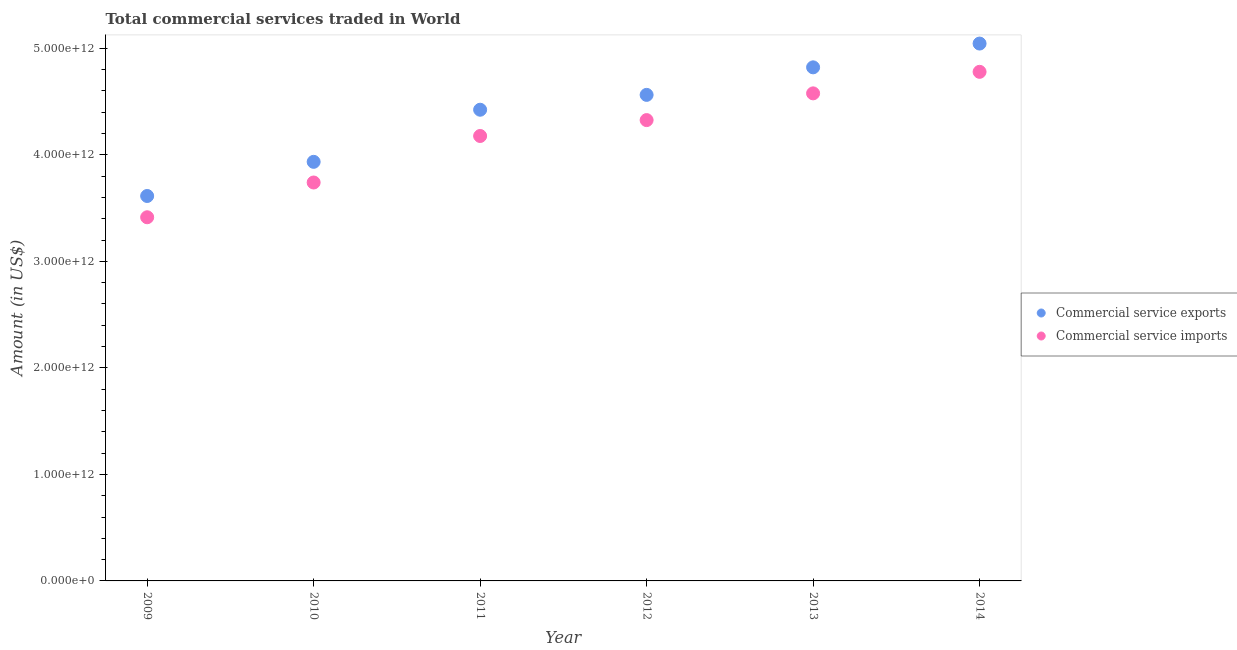What is the amount of commercial service exports in 2011?
Your answer should be compact. 4.42e+12. Across all years, what is the maximum amount of commercial service imports?
Your response must be concise. 4.78e+12. Across all years, what is the minimum amount of commercial service exports?
Keep it short and to the point. 3.61e+12. In which year was the amount of commercial service imports minimum?
Give a very brief answer. 2009. What is the total amount of commercial service exports in the graph?
Make the answer very short. 2.64e+13. What is the difference between the amount of commercial service exports in 2011 and that in 2014?
Provide a succinct answer. -6.21e+11. What is the difference between the amount of commercial service exports in 2011 and the amount of commercial service imports in 2012?
Give a very brief answer. 9.73e+1. What is the average amount of commercial service imports per year?
Your response must be concise. 4.17e+12. In the year 2013, what is the difference between the amount of commercial service exports and amount of commercial service imports?
Provide a short and direct response. 2.44e+11. In how many years, is the amount of commercial service exports greater than 1000000000000 US$?
Your answer should be compact. 6. What is the ratio of the amount of commercial service imports in 2011 to that in 2014?
Keep it short and to the point. 0.87. Is the amount of commercial service imports in 2010 less than that in 2011?
Make the answer very short. Yes. What is the difference between the highest and the second highest amount of commercial service imports?
Provide a succinct answer. 2.02e+11. What is the difference between the highest and the lowest amount of commercial service imports?
Provide a short and direct response. 1.37e+12. In how many years, is the amount of commercial service imports greater than the average amount of commercial service imports taken over all years?
Offer a terse response. 4. Is the sum of the amount of commercial service imports in 2011 and 2012 greater than the maximum amount of commercial service exports across all years?
Give a very brief answer. Yes. Is the amount of commercial service exports strictly greater than the amount of commercial service imports over the years?
Your answer should be very brief. Yes. What is the difference between two consecutive major ticks on the Y-axis?
Ensure brevity in your answer.  1.00e+12. Are the values on the major ticks of Y-axis written in scientific E-notation?
Provide a succinct answer. Yes. How are the legend labels stacked?
Make the answer very short. Vertical. What is the title of the graph?
Your response must be concise. Total commercial services traded in World. Does "Private creditors" appear as one of the legend labels in the graph?
Your answer should be very brief. No. What is the label or title of the Y-axis?
Make the answer very short. Amount (in US$). What is the Amount (in US$) of Commercial service exports in 2009?
Offer a very short reply. 3.61e+12. What is the Amount (in US$) of Commercial service imports in 2009?
Your response must be concise. 3.41e+12. What is the Amount (in US$) of Commercial service exports in 2010?
Offer a very short reply. 3.93e+12. What is the Amount (in US$) of Commercial service imports in 2010?
Make the answer very short. 3.74e+12. What is the Amount (in US$) in Commercial service exports in 2011?
Your answer should be very brief. 4.42e+12. What is the Amount (in US$) in Commercial service imports in 2011?
Your answer should be very brief. 4.18e+12. What is the Amount (in US$) of Commercial service exports in 2012?
Keep it short and to the point. 4.56e+12. What is the Amount (in US$) of Commercial service imports in 2012?
Your answer should be very brief. 4.33e+12. What is the Amount (in US$) of Commercial service exports in 2013?
Your answer should be very brief. 4.82e+12. What is the Amount (in US$) in Commercial service imports in 2013?
Keep it short and to the point. 4.58e+12. What is the Amount (in US$) of Commercial service exports in 2014?
Provide a succinct answer. 5.04e+12. What is the Amount (in US$) in Commercial service imports in 2014?
Ensure brevity in your answer.  4.78e+12. Across all years, what is the maximum Amount (in US$) in Commercial service exports?
Make the answer very short. 5.04e+12. Across all years, what is the maximum Amount (in US$) of Commercial service imports?
Provide a succinct answer. 4.78e+12. Across all years, what is the minimum Amount (in US$) in Commercial service exports?
Make the answer very short. 3.61e+12. Across all years, what is the minimum Amount (in US$) in Commercial service imports?
Provide a succinct answer. 3.41e+12. What is the total Amount (in US$) of Commercial service exports in the graph?
Ensure brevity in your answer.  2.64e+13. What is the total Amount (in US$) of Commercial service imports in the graph?
Your answer should be very brief. 2.50e+13. What is the difference between the Amount (in US$) in Commercial service exports in 2009 and that in 2010?
Ensure brevity in your answer.  -3.21e+11. What is the difference between the Amount (in US$) of Commercial service imports in 2009 and that in 2010?
Your response must be concise. -3.26e+11. What is the difference between the Amount (in US$) in Commercial service exports in 2009 and that in 2011?
Your response must be concise. -8.10e+11. What is the difference between the Amount (in US$) of Commercial service imports in 2009 and that in 2011?
Give a very brief answer. -7.63e+11. What is the difference between the Amount (in US$) in Commercial service exports in 2009 and that in 2012?
Your answer should be very brief. -9.49e+11. What is the difference between the Amount (in US$) in Commercial service imports in 2009 and that in 2012?
Provide a succinct answer. -9.12e+11. What is the difference between the Amount (in US$) of Commercial service exports in 2009 and that in 2013?
Give a very brief answer. -1.21e+12. What is the difference between the Amount (in US$) in Commercial service imports in 2009 and that in 2013?
Give a very brief answer. -1.16e+12. What is the difference between the Amount (in US$) in Commercial service exports in 2009 and that in 2014?
Provide a short and direct response. -1.43e+12. What is the difference between the Amount (in US$) in Commercial service imports in 2009 and that in 2014?
Provide a short and direct response. -1.37e+12. What is the difference between the Amount (in US$) in Commercial service exports in 2010 and that in 2011?
Your answer should be compact. -4.89e+11. What is the difference between the Amount (in US$) in Commercial service imports in 2010 and that in 2011?
Make the answer very short. -4.37e+11. What is the difference between the Amount (in US$) of Commercial service exports in 2010 and that in 2012?
Your response must be concise. -6.29e+11. What is the difference between the Amount (in US$) of Commercial service imports in 2010 and that in 2012?
Ensure brevity in your answer.  -5.86e+11. What is the difference between the Amount (in US$) of Commercial service exports in 2010 and that in 2013?
Provide a short and direct response. -8.87e+11. What is the difference between the Amount (in US$) of Commercial service imports in 2010 and that in 2013?
Offer a terse response. -8.37e+11. What is the difference between the Amount (in US$) in Commercial service exports in 2010 and that in 2014?
Make the answer very short. -1.11e+12. What is the difference between the Amount (in US$) of Commercial service imports in 2010 and that in 2014?
Ensure brevity in your answer.  -1.04e+12. What is the difference between the Amount (in US$) of Commercial service exports in 2011 and that in 2012?
Provide a succinct answer. -1.39e+11. What is the difference between the Amount (in US$) of Commercial service imports in 2011 and that in 2012?
Your response must be concise. -1.49e+11. What is the difference between the Amount (in US$) of Commercial service exports in 2011 and that in 2013?
Provide a succinct answer. -3.98e+11. What is the difference between the Amount (in US$) of Commercial service imports in 2011 and that in 2013?
Give a very brief answer. -4.00e+11. What is the difference between the Amount (in US$) of Commercial service exports in 2011 and that in 2014?
Your response must be concise. -6.21e+11. What is the difference between the Amount (in US$) in Commercial service imports in 2011 and that in 2014?
Your answer should be very brief. -6.02e+11. What is the difference between the Amount (in US$) in Commercial service exports in 2012 and that in 2013?
Offer a very short reply. -2.58e+11. What is the difference between the Amount (in US$) in Commercial service imports in 2012 and that in 2013?
Make the answer very short. -2.51e+11. What is the difference between the Amount (in US$) in Commercial service exports in 2012 and that in 2014?
Provide a succinct answer. -4.82e+11. What is the difference between the Amount (in US$) of Commercial service imports in 2012 and that in 2014?
Offer a very short reply. -4.53e+11. What is the difference between the Amount (in US$) in Commercial service exports in 2013 and that in 2014?
Your answer should be compact. -2.23e+11. What is the difference between the Amount (in US$) of Commercial service imports in 2013 and that in 2014?
Your answer should be compact. -2.02e+11. What is the difference between the Amount (in US$) of Commercial service exports in 2009 and the Amount (in US$) of Commercial service imports in 2010?
Offer a terse response. -1.27e+11. What is the difference between the Amount (in US$) in Commercial service exports in 2009 and the Amount (in US$) in Commercial service imports in 2011?
Offer a terse response. -5.63e+11. What is the difference between the Amount (in US$) in Commercial service exports in 2009 and the Amount (in US$) in Commercial service imports in 2012?
Provide a short and direct response. -7.12e+11. What is the difference between the Amount (in US$) of Commercial service exports in 2009 and the Amount (in US$) of Commercial service imports in 2013?
Offer a terse response. -9.63e+11. What is the difference between the Amount (in US$) in Commercial service exports in 2009 and the Amount (in US$) in Commercial service imports in 2014?
Keep it short and to the point. -1.17e+12. What is the difference between the Amount (in US$) in Commercial service exports in 2010 and the Amount (in US$) in Commercial service imports in 2011?
Make the answer very short. -2.43e+11. What is the difference between the Amount (in US$) of Commercial service exports in 2010 and the Amount (in US$) of Commercial service imports in 2012?
Make the answer very short. -3.92e+11. What is the difference between the Amount (in US$) in Commercial service exports in 2010 and the Amount (in US$) in Commercial service imports in 2013?
Make the answer very short. -6.43e+11. What is the difference between the Amount (in US$) in Commercial service exports in 2010 and the Amount (in US$) in Commercial service imports in 2014?
Give a very brief answer. -8.45e+11. What is the difference between the Amount (in US$) in Commercial service exports in 2011 and the Amount (in US$) in Commercial service imports in 2012?
Ensure brevity in your answer.  9.73e+1. What is the difference between the Amount (in US$) of Commercial service exports in 2011 and the Amount (in US$) of Commercial service imports in 2013?
Keep it short and to the point. -1.54e+11. What is the difference between the Amount (in US$) of Commercial service exports in 2011 and the Amount (in US$) of Commercial service imports in 2014?
Provide a succinct answer. -3.56e+11. What is the difference between the Amount (in US$) of Commercial service exports in 2012 and the Amount (in US$) of Commercial service imports in 2013?
Provide a short and direct response. -1.42e+1. What is the difference between the Amount (in US$) of Commercial service exports in 2012 and the Amount (in US$) of Commercial service imports in 2014?
Your answer should be very brief. -2.16e+11. What is the difference between the Amount (in US$) of Commercial service exports in 2013 and the Amount (in US$) of Commercial service imports in 2014?
Offer a terse response. 4.22e+1. What is the average Amount (in US$) of Commercial service exports per year?
Your answer should be very brief. 4.40e+12. What is the average Amount (in US$) of Commercial service imports per year?
Make the answer very short. 4.17e+12. In the year 2009, what is the difference between the Amount (in US$) in Commercial service exports and Amount (in US$) in Commercial service imports?
Your answer should be compact. 2.00e+11. In the year 2010, what is the difference between the Amount (in US$) in Commercial service exports and Amount (in US$) in Commercial service imports?
Provide a short and direct response. 1.94e+11. In the year 2011, what is the difference between the Amount (in US$) of Commercial service exports and Amount (in US$) of Commercial service imports?
Give a very brief answer. 2.46e+11. In the year 2012, what is the difference between the Amount (in US$) in Commercial service exports and Amount (in US$) in Commercial service imports?
Provide a succinct answer. 2.37e+11. In the year 2013, what is the difference between the Amount (in US$) in Commercial service exports and Amount (in US$) in Commercial service imports?
Your answer should be very brief. 2.44e+11. In the year 2014, what is the difference between the Amount (in US$) in Commercial service exports and Amount (in US$) in Commercial service imports?
Your answer should be compact. 2.65e+11. What is the ratio of the Amount (in US$) in Commercial service exports in 2009 to that in 2010?
Keep it short and to the point. 0.92. What is the ratio of the Amount (in US$) of Commercial service imports in 2009 to that in 2010?
Ensure brevity in your answer.  0.91. What is the ratio of the Amount (in US$) in Commercial service exports in 2009 to that in 2011?
Your answer should be compact. 0.82. What is the ratio of the Amount (in US$) in Commercial service imports in 2009 to that in 2011?
Your answer should be compact. 0.82. What is the ratio of the Amount (in US$) of Commercial service exports in 2009 to that in 2012?
Provide a succinct answer. 0.79. What is the ratio of the Amount (in US$) in Commercial service imports in 2009 to that in 2012?
Provide a short and direct response. 0.79. What is the ratio of the Amount (in US$) in Commercial service exports in 2009 to that in 2013?
Offer a terse response. 0.75. What is the ratio of the Amount (in US$) of Commercial service imports in 2009 to that in 2013?
Keep it short and to the point. 0.75. What is the ratio of the Amount (in US$) in Commercial service exports in 2009 to that in 2014?
Keep it short and to the point. 0.72. What is the ratio of the Amount (in US$) of Commercial service exports in 2010 to that in 2011?
Ensure brevity in your answer.  0.89. What is the ratio of the Amount (in US$) in Commercial service imports in 2010 to that in 2011?
Provide a short and direct response. 0.9. What is the ratio of the Amount (in US$) in Commercial service exports in 2010 to that in 2012?
Offer a terse response. 0.86. What is the ratio of the Amount (in US$) of Commercial service imports in 2010 to that in 2012?
Provide a succinct answer. 0.86. What is the ratio of the Amount (in US$) in Commercial service exports in 2010 to that in 2013?
Keep it short and to the point. 0.82. What is the ratio of the Amount (in US$) in Commercial service imports in 2010 to that in 2013?
Give a very brief answer. 0.82. What is the ratio of the Amount (in US$) of Commercial service exports in 2010 to that in 2014?
Your response must be concise. 0.78. What is the ratio of the Amount (in US$) of Commercial service imports in 2010 to that in 2014?
Offer a terse response. 0.78. What is the ratio of the Amount (in US$) in Commercial service exports in 2011 to that in 2012?
Give a very brief answer. 0.97. What is the ratio of the Amount (in US$) in Commercial service imports in 2011 to that in 2012?
Your answer should be very brief. 0.97. What is the ratio of the Amount (in US$) in Commercial service exports in 2011 to that in 2013?
Your answer should be compact. 0.92. What is the ratio of the Amount (in US$) in Commercial service imports in 2011 to that in 2013?
Provide a short and direct response. 0.91. What is the ratio of the Amount (in US$) in Commercial service exports in 2011 to that in 2014?
Your answer should be compact. 0.88. What is the ratio of the Amount (in US$) in Commercial service imports in 2011 to that in 2014?
Provide a succinct answer. 0.87. What is the ratio of the Amount (in US$) of Commercial service exports in 2012 to that in 2013?
Make the answer very short. 0.95. What is the ratio of the Amount (in US$) in Commercial service imports in 2012 to that in 2013?
Your answer should be compact. 0.95. What is the ratio of the Amount (in US$) of Commercial service exports in 2012 to that in 2014?
Your answer should be compact. 0.9. What is the ratio of the Amount (in US$) of Commercial service imports in 2012 to that in 2014?
Give a very brief answer. 0.91. What is the ratio of the Amount (in US$) in Commercial service exports in 2013 to that in 2014?
Keep it short and to the point. 0.96. What is the ratio of the Amount (in US$) in Commercial service imports in 2013 to that in 2014?
Your answer should be very brief. 0.96. What is the difference between the highest and the second highest Amount (in US$) of Commercial service exports?
Provide a succinct answer. 2.23e+11. What is the difference between the highest and the second highest Amount (in US$) of Commercial service imports?
Provide a short and direct response. 2.02e+11. What is the difference between the highest and the lowest Amount (in US$) in Commercial service exports?
Keep it short and to the point. 1.43e+12. What is the difference between the highest and the lowest Amount (in US$) of Commercial service imports?
Your answer should be very brief. 1.37e+12. 